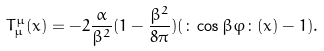<formula> <loc_0><loc_0><loc_500><loc_500>T _ { \mu } ^ { \mu } ( x ) = - 2 \frac { \alpha } { \beta ^ { 2 } } ( 1 - \frac { \beta ^ { 2 } } { 8 \pi } ) ( \colon \cos \beta \varphi \colon ( x ) - 1 ) .</formula> 